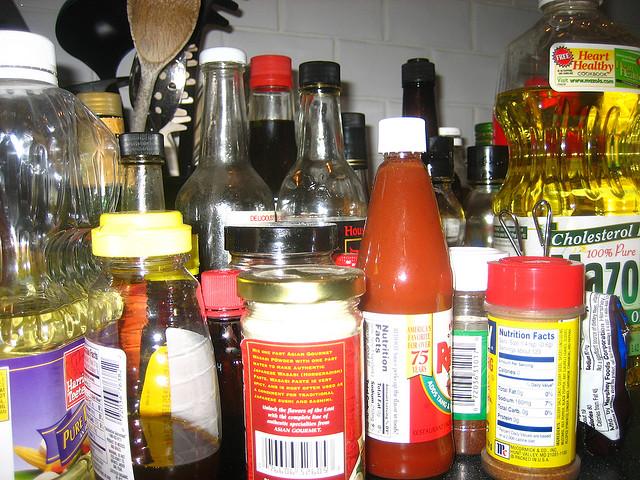Is there cooking oil in the picture?
Keep it brief. Yes. How many plastic bottles are there in the picture?
Keep it brief. 7. What kind of honey is this?
Write a very short answer. Clover. What color is the top of the hot sauce bottle?
Give a very brief answer. White. 